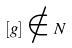<formula> <loc_0><loc_0><loc_500><loc_500>[ g ] \notin N</formula> 